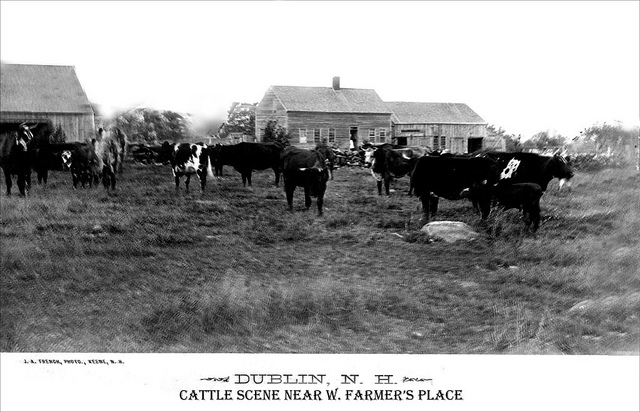Please transcribe the text information in this image. DUBLIN, CATTLE SCENE NEAR W FARMER'S PLACE H N WELL 